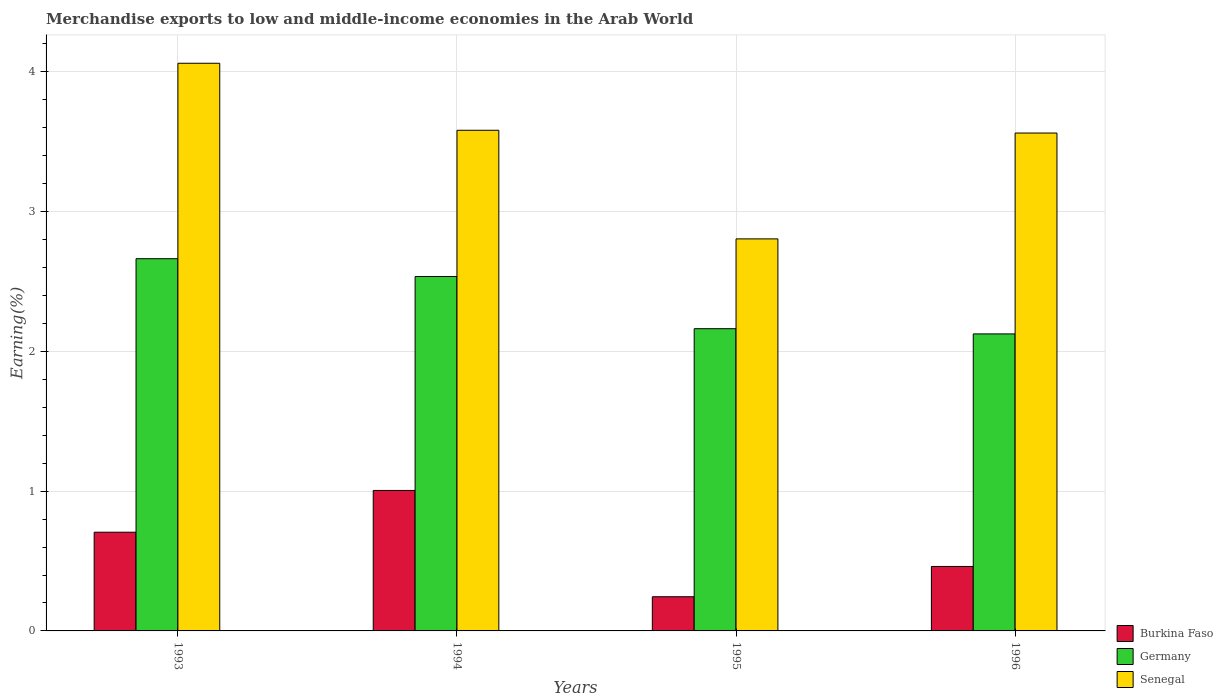How many different coloured bars are there?
Provide a short and direct response. 3. In how many cases, is the number of bars for a given year not equal to the number of legend labels?
Keep it short and to the point. 0. What is the percentage of amount earned from merchandise exports in Germany in 1996?
Keep it short and to the point. 2.12. Across all years, what is the maximum percentage of amount earned from merchandise exports in Germany?
Your answer should be very brief. 2.66. Across all years, what is the minimum percentage of amount earned from merchandise exports in Senegal?
Your response must be concise. 2.8. In which year was the percentage of amount earned from merchandise exports in Senegal maximum?
Your answer should be compact. 1993. What is the total percentage of amount earned from merchandise exports in Germany in the graph?
Give a very brief answer. 9.48. What is the difference between the percentage of amount earned from merchandise exports in Burkina Faso in 1993 and that in 1995?
Keep it short and to the point. 0.46. What is the difference between the percentage of amount earned from merchandise exports in Germany in 1993 and the percentage of amount earned from merchandise exports in Burkina Faso in 1996?
Provide a short and direct response. 2.2. What is the average percentage of amount earned from merchandise exports in Senegal per year?
Make the answer very short. 3.5. In the year 1994, what is the difference between the percentage of amount earned from merchandise exports in Senegal and percentage of amount earned from merchandise exports in Germany?
Give a very brief answer. 1.05. What is the ratio of the percentage of amount earned from merchandise exports in Germany in 1993 to that in 1996?
Ensure brevity in your answer.  1.25. Is the percentage of amount earned from merchandise exports in Germany in 1993 less than that in 1995?
Your response must be concise. No. Is the difference between the percentage of amount earned from merchandise exports in Senegal in 1995 and 1996 greater than the difference between the percentage of amount earned from merchandise exports in Germany in 1995 and 1996?
Your answer should be compact. No. What is the difference between the highest and the second highest percentage of amount earned from merchandise exports in Burkina Faso?
Offer a very short reply. 0.3. What is the difference between the highest and the lowest percentage of amount earned from merchandise exports in Senegal?
Ensure brevity in your answer.  1.26. Is the sum of the percentage of amount earned from merchandise exports in Senegal in 1993 and 1995 greater than the maximum percentage of amount earned from merchandise exports in Germany across all years?
Ensure brevity in your answer.  Yes. What does the 2nd bar from the left in 1993 represents?
Ensure brevity in your answer.  Germany. What does the 3rd bar from the right in 1994 represents?
Offer a terse response. Burkina Faso. Is it the case that in every year, the sum of the percentage of amount earned from merchandise exports in Burkina Faso and percentage of amount earned from merchandise exports in Senegal is greater than the percentage of amount earned from merchandise exports in Germany?
Give a very brief answer. Yes. How many bars are there?
Your answer should be compact. 12. What is the difference between two consecutive major ticks on the Y-axis?
Provide a short and direct response. 1. Are the values on the major ticks of Y-axis written in scientific E-notation?
Offer a terse response. No. Does the graph contain any zero values?
Offer a very short reply. No. How are the legend labels stacked?
Provide a short and direct response. Vertical. What is the title of the graph?
Provide a short and direct response. Merchandise exports to low and middle-income economies in the Arab World. What is the label or title of the Y-axis?
Make the answer very short. Earning(%). What is the Earning(%) of Burkina Faso in 1993?
Ensure brevity in your answer.  0.71. What is the Earning(%) of Germany in 1993?
Give a very brief answer. 2.66. What is the Earning(%) in Senegal in 1993?
Give a very brief answer. 4.06. What is the Earning(%) in Burkina Faso in 1994?
Your answer should be very brief. 1.01. What is the Earning(%) in Germany in 1994?
Your answer should be compact. 2.54. What is the Earning(%) of Senegal in 1994?
Provide a short and direct response. 3.58. What is the Earning(%) in Burkina Faso in 1995?
Ensure brevity in your answer.  0.24. What is the Earning(%) in Germany in 1995?
Keep it short and to the point. 2.16. What is the Earning(%) of Senegal in 1995?
Offer a very short reply. 2.8. What is the Earning(%) in Burkina Faso in 1996?
Keep it short and to the point. 0.46. What is the Earning(%) of Germany in 1996?
Give a very brief answer. 2.12. What is the Earning(%) of Senegal in 1996?
Offer a terse response. 3.56. Across all years, what is the maximum Earning(%) in Burkina Faso?
Give a very brief answer. 1.01. Across all years, what is the maximum Earning(%) in Germany?
Offer a very short reply. 2.66. Across all years, what is the maximum Earning(%) in Senegal?
Make the answer very short. 4.06. Across all years, what is the minimum Earning(%) of Burkina Faso?
Provide a short and direct response. 0.24. Across all years, what is the minimum Earning(%) in Germany?
Make the answer very short. 2.12. Across all years, what is the minimum Earning(%) of Senegal?
Offer a very short reply. 2.8. What is the total Earning(%) in Burkina Faso in the graph?
Make the answer very short. 2.42. What is the total Earning(%) of Germany in the graph?
Provide a short and direct response. 9.48. What is the total Earning(%) of Senegal in the graph?
Offer a terse response. 14.01. What is the difference between the Earning(%) in Burkina Faso in 1993 and that in 1994?
Offer a terse response. -0.3. What is the difference between the Earning(%) in Germany in 1993 and that in 1994?
Provide a succinct answer. 0.13. What is the difference between the Earning(%) of Senegal in 1993 and that in 1994?
Provide a succinct answer. 0.48. What is the difference between the Earning(%) of Burkina Faso in 1993 and that in 1995?
Give a very brief answer. 0.46. What is the difference between the Earning(%) in Germany in 1993 and that in 1995?
Offer a very short reply. 0.5. What is the difference between the Earning(%) in Senegal in 1993 and that in 1995?
Offer a very short reply. 1.26. What is the difference between the Earning(%) in Burkina Faso in 1993 and that in 1996?
Offer a terse response. 0.24. What is the difference between the Earning(%) in Germany in 1993 and that in 1996?
Keep it short and to the point. 0.54. What is the difference between the Earning(%) in Senegal in 1993 and that in 1996?
Your answer should be compact. 0.5. What is the difference between the Earning(%) of Burkina Faso in 1994 and that in 1995?
Your answer should be very brief. 0.76. What is the difference between the Earning(%) of Germany in 1994 and that in 1995?
Your response must be concise. 0.37. What is the difference between the Earning(%) of Senegal in 1994 and that in 1995?
Provide a succinct answer. 0.78. What is the difference between the Earning(%) in Burkina Faso in 1994 and that in 1996?
Your response must be concise. 0.54. What is the difference between the Earning(%) of Germany in 1994 and that in 1996?
Make the answer very short. 0.41. What is the difference between the Earning(%) of Senegal in 1994 and that in 1996?
Your answer should be compact. 0.02. What is the difference between the Earning(%) in Burkina Faso in 1995 and that in 1996?
Give a very brief answer. -0.22. What is the difference between the Earning(%) of Germany in 1995 and that in 1996?
Offer a very short reply. 0.04. What is the difference between the Earning(%) of Senegal in 1995 and that in 1996?
Make the answer very short. -0.76. What is the difference between the Earning(%) in Burkina Faso in 1993 and the Earning(%) in Germany in 1994?
Offer a terse response. -1.83. What is the difference between the Earning(%) of Burkina Faso in 1993 and the Earning(%) of Senegal in 1994?
Keep it short and to the point. -2.88. What is the difference between the Earning(%) of Germany in 1993 and the Earning(%) of Senegal in 1994?
Ensure brevity in your answer.  -0.92. What is the difference between the Earning(%) of Burkina Faso in 1993 and the Earning(%) of Germany in 1995?
Provide a succinct answer. -1.46. What is the difference between the Earning(%) in Burkina Faso in 1993 and the Earning(%) in Senegal in 1995?
Ensure brevity in your answer.  -2.1. What is the difference between the Earning(%) of Germany in 1993 and the Earning(%) of Senegal in 1995?
Offer a terse response. -0.14. What is the difference between the Earning(%) of Burkina Faso in 1993 and the Earning(%) of Germany in 1996?
Provide a succinct answer. -1.42. What is the difference between the Earning(%) in Burkina Faso in 1993 and the Earning(%) in Senegal in 1996?
Your response must be concise. -2.86. What is the difference between the Earning(%) of Germany in 1993 and the Earning(%) of Senegal in 1996?
Make the answer very short. -0.9. What is the difference between the Earning(%) of Burkina Faso in 1994 and the Earning(%) of Germany in 1995?
Offer a very short reply. -1.16. What is the difference between the Earning(%) in Burkina Faso in 1994 and the Earning(%) in Senegal in 1995?
Ensure brevity in your answer.  -1.8. What is the difference between the Earning(%) of Germany in 1994 and the Earning(%) of Senegal in 1995?
Ensure brevity in your answer.  -0.27. What is the difference between the Earning(%) in Burkina Faso in 1994 and the Earning(%) in Germany in 1996?
Your answer should be very brief. -1.12. What is the difference between the Earning(%) of Burkina Faso in 1994 and the Earning(%) of Senegal in 1996?
Your response must be concise. -2.56. What is the difference between the Earning(%) of Germany in 1994 and the Earning(%) of Senegal in 1996?
Your answer should be compact. -1.03. What is the difference between the Earning(%) of Burkina Faso in 1995 and the Earning(%) of Germany in 1996?
Your response must be concise. -1.88. What is the difference between the Earning(%) in Burkina Faso in 1995 and the Earning(%) in Senegal in 1996?
Ensure brevity in your answer.  -3.32. What is the difference between the Earning(%) of Germany in 1995 and the Earning(%) of Senegal in 1996?
Provide a succinct answer. -1.4. What is the average Earning(%) in Burkina Faso per year?
Give a very brief answer. 0.6. What is the average Earning(%) in Germany per year?
Make the answer very short. 2.37. What is the average Earning(%) of Senegal per year?
Your answer should be very brief. 3.5. In the year 1993, what is the difference between the Earning(%) of Burkina Faso and Earning(%) of Germany?
Offer a very short reply. -1.96. In the year 1993, what is the difference between the Earning(%) of Burkina Faso and Earning(%) of Senegal?
Ensure brevity in your answer.  -3.35. In the year 1993, what is the difference between the Earning(%) of Germany and Earning(%) of Senegal?
Your response must be concise. -1.4. In the year 1994, what is the difference between the Earning(%) in Burkina Faso and Earning(%) in Germany?
Ensure brevity in your answer.  -1.53. In the year 1994, what is the difference between the Earning(%) in Burkina Faso and Earning(%) in Senegal?
Make the answer very short. -2.58. In the year 1994, what is the difference between the Earning(%) in Germany and Earning(%) in Senegal?
Your answer should be very brief. -1.05. In the year 1995, what is the difference between the Earning(%) of Burkina Faso and Earning(%) of Germany?
Your response must be concise. -1.92. In the year 1995, what is the difference between the Earning(%) in Burkina Faso and Earning(%) in Senegal?
Your answer should be compact. -2.56. In the year 1995, what is the difference between the Earning(%) in Germany and Earning(%) in Senegal?
Make the answer very short. -0.64. In the year 1996, what is the difference between the Earning(%) in Burkina Faso and Earning(%) in Germany?
Offer a terse response. -1.66. In the year 1996, what is the difference between the Earning(%) of Burkina Faso and Earning(%) of Senegal?
Provide a short and direct response. -3.1. In the year 1996, what is the difference between the Earning(%) of Germany and Earning(%) of Senegal?
Your answer should be compact. -1.44. What is the ratio of the Earning(%) of Burkina Faso in 1993 to that in 1994?
Make the answer very short. 0.7. What is the ratio of the Earning(%) of Germany in 1993 to that in 1994?
Give a very brief answer. 1.05. What is the ratio of the Earning(%) in Senegal in 1993 to that in 1994?
Ensure brevity in your answer.  1.13. What is the ratio of the Earning(%) in Burkina Faso in 1993 to that in 1995?
Provide a succinct answer. 2.89. What is the ratio of the Earning(%) of Germany in 1993 to that in 1995?
Your response must be concise. 1.23. What is the ratio of the Earning(%) in Senegal in 1993 to that in 1995?
Your response must be concise. 1.45. What is the ratio of the Earning(%) of Burkina Faso in 1993 to that in 1996?
Make the answer very short. 1.53. What is the ratio of the Earning(%) of Germany in 1993 to that in 1996?
Ensure brevity in your answer.  1.25. What is the ratio of the Earning(%) in Senegal in 1993 to that in 1996?
Provide a succinct answer. 1.14. What is the ratio of the Earning(%) in Burkina Faso in 1994 to that in 1995?
Offer a very short reply. 4.11. What is the ratio of the Earning(%) of Germany in 1994 to that in 1995?
Make the answer very short. 1.17. What is the ratio of the Earning(%) of Senegal in 1994 to that in 1995?
Make the answer very short. 1.28. What is the ratio of the Earning(%) of Burkina Faso in 1994 to that in 1996?
Offer a terse response. 2.18. What is the ratio of the Earning(%) in Germany in 1994 to that in 1996?
Your response must be concise. 1.19. What is the ratio of the Earning(%) of Senegal in 1994 to that in 1996?
Ensure brevity in your answer.  1.01. What is the ratio of the Earning(%) of Burkina Faso in 1995 to that in 1996?
Ensure brevity in your answer.  0.53. What is the ratio of the Earning(%) in Germany in 1995 to that in 1996?
Provide a succinct answer. 1.02. What is the ratio of the Earning(%) in Senegal in 1995 to that in 1996?
Provide a succinct answer. 0.79. What is the difference between the highest and the second highest Earning(%) of Burkina Faso?
Your response must be concise. 0.3. What is the difference between the highest and the second highest Earning(%) in Germany?
Your answer should be very brief. 0.13. What is the difference between the highest and the second highest Earning(%) of Senegal?
Ensure brevity in your answer.  0.48. What is the difference between the highest and the lowest Earning(%) in Burkina Faso?
Offer a very short reply. 0.76. What is the difference between the highest and the lowest Earning(%) of Germany?
Your answer should be very brief. 0.54. What is the difference between the highest and the lowest Earning(%) of Senegal?
Provide a succinct answer. 1.26. 